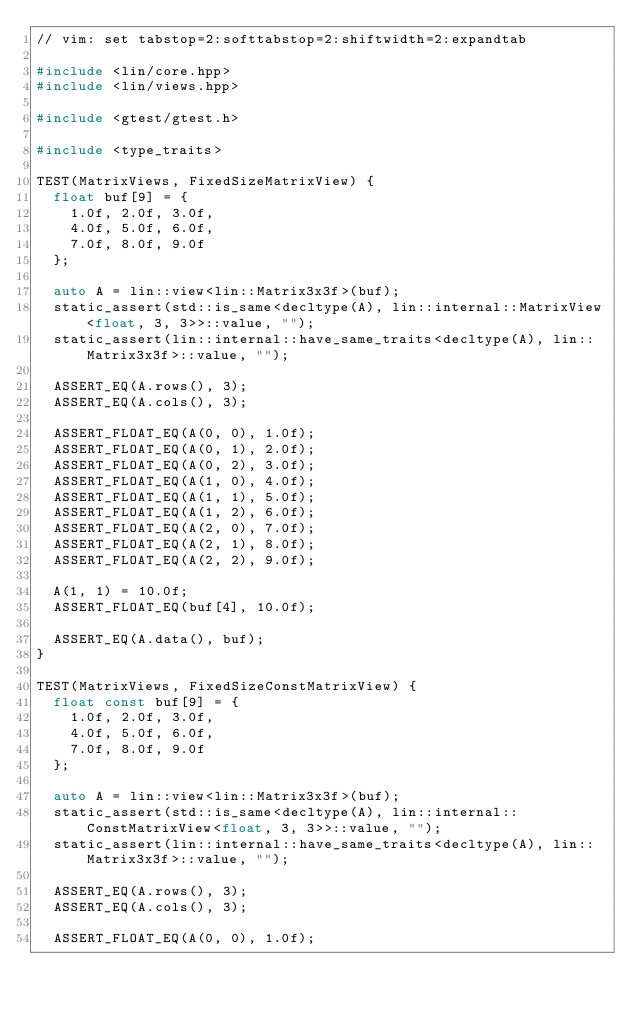Convert code to text. <code><loc_0><loc_0><loc_500><loc_500><_C++_>// vim: set tabstop=2:softtabstop=2:shiftwidth=2:expandtab

#include <lin/core.hpp>
#include <lin/views.hpp>

#include <gtest/gtest.h>

#include <type_traits>

TEST(MatrixViews, FixedSizeMatrixView) {
  float buf[9] = {
    1.0f, 2.0f, 3.0f,
    4.0f, 5.0f, 6.0f,
    7.0f, 8.0f, 9.0f
  };

  auto A = lin::view<lin::Matrix3x3f>(buf);
  static_assert(std::is_same<decltype(A), lin::internal::MatrixView<float, 3, 3>>::value, "");
  static_assert(lin::internal::have_same_traits<decltype(A), lin::Matrix3x3f>::value, "");

  ASSERT_EQ(A.rows(), 3);
  ASSERT_EQ(A.cols(), 3);

  ASSERT_FLOAT_EQ(A(0, 0), 1.0f);
  ASSERT_FLOAT_EQ(A(0, 1), 2.0f);
  ASSERT_FLOAT_EQ(A(0, 2), 3.0f);
  ASSERT_FLOAT_EQ(A(1, 0), 4.0f);
  ASSERT_FLOAT_EQ(A(1, 1), 5.0f);
  ASSERT_FLOAT_EQ(A(1, 2), 6.0f);
  ASSERT_FLOAT_EQ(A(2, 0), 7.0f);
  ASSERT_FLOAT_EQ(A(2, 1), 8.0f);
  ASSERT_FLOAT_EQ(A(2, 2), 9.0f);

  A(1, 1) = 10.0f;
  ASSERT_FLOAT_EQ(buf[4], 10.0f);

  ASSERT_EQ(A.data(), buf);
}

TEST(MatrixViews, FixedSizeConstMatrixView) {
  float const buf[9] = {
    1.0f, 2.0f, 3.0f,
    4.0f, 5.0f, 6.0f,
    7.0f, 8.0f, 9.0f
  };

  auto A = lin::view<lin::Matrix3x3f>(buf);
  static_assert(std::is_same<decltype(A), lin::internal::ConstMatrixView<float, 3, 3>>::value, "");
  static_assert(lin::internal::have_same_traits<decltype(A), lin::Matrix3x3f>::value, "");

  ASSERT_EQ(A.rows(), 3);
  ASSERT_EQ(A.cols(), 3);

  ASSERT_FLOAT_EQ(A(0, 0), 1.0f);</code> 